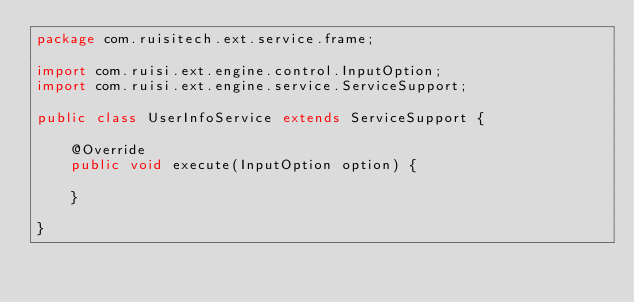Convert code to text. <code><loc_0><loc_0><loc_500><loc_500><_Java_>package com.ruisitech.ext.service.frame;

import com.ruisi.ext.engine.control.InputOption;
import com.ruisi.ext.engine.service.ServiceSupport;

public class UserInfoService extends ServiceSupport {

	@Override
	public void execute(InputOption option) {
		
	}

}
</code> 